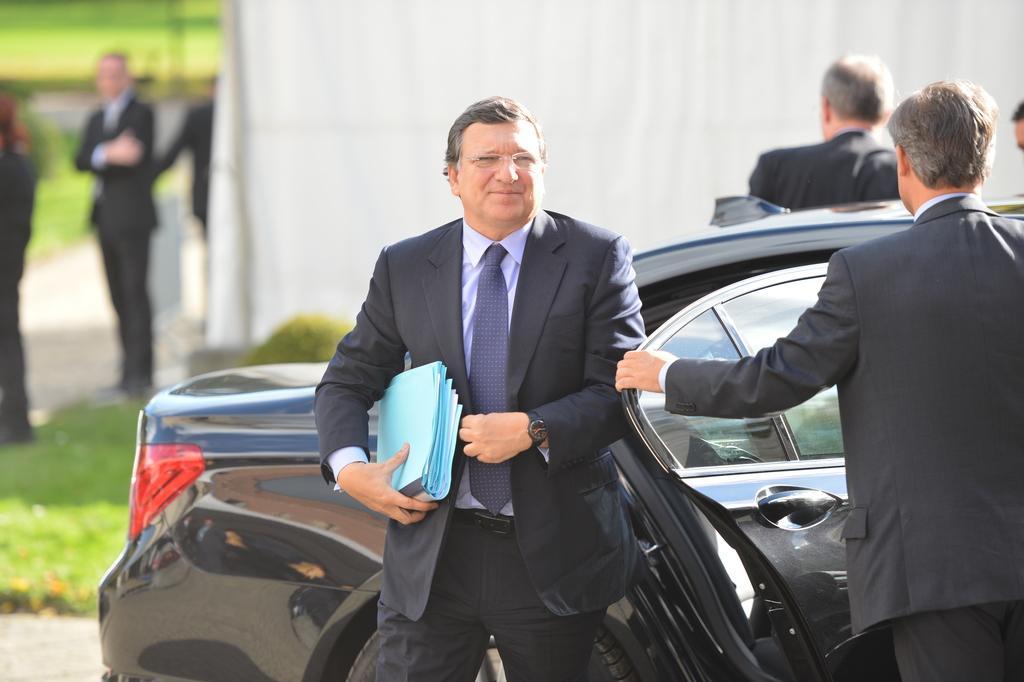Could you give a brief overview of what you see in this image? In this image there is a black color car. There are two persons in the foreground of the image wearing suit. In the background of the image there are people standing. There is a white color cloth. There is grass. At the bottom of the image there is road. 